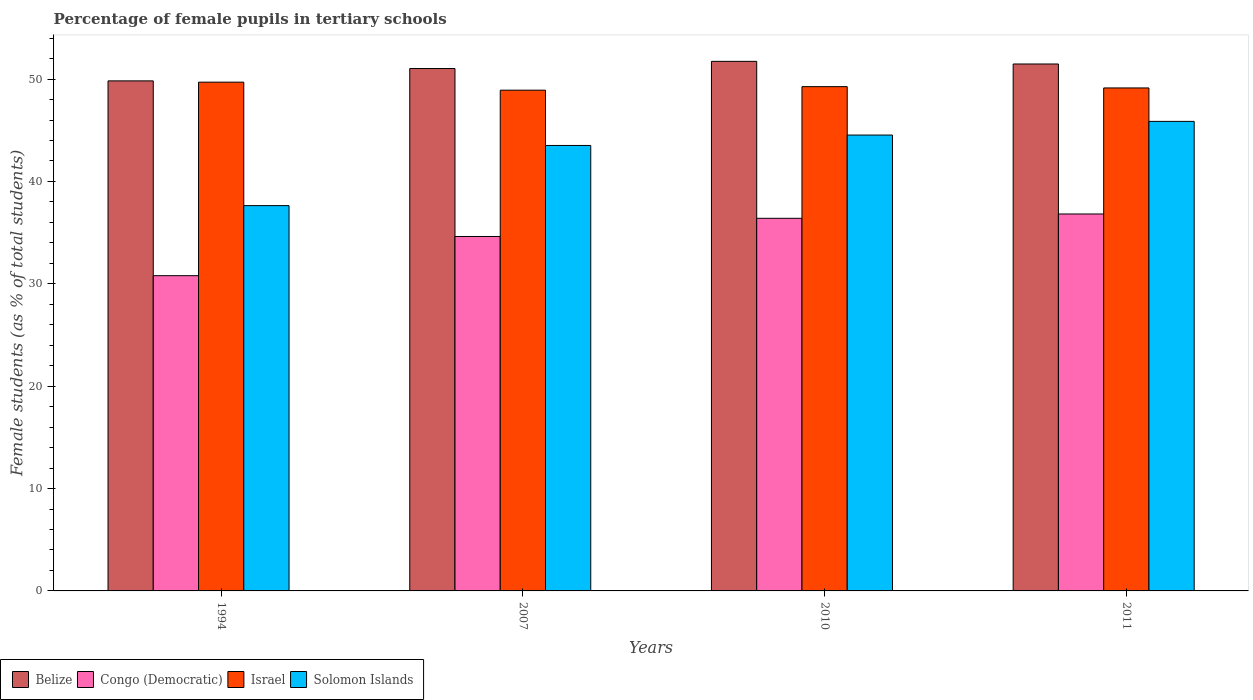How many bars are there on the 2nd tick from the left?
Ensure brevity in your answer.  4. In how many cases, is the number of bars for a given year not equal to the number of legend labels?
Your answer should be compact. 0. What is the percentage of female pupils in tertiary schools in Israel in 2011?
Offer a terse response. 49.14. Across all years, what is the maximum percentage of female pupils in tertiary schools in Solomon Islands?
Offer a terse response. 45.87. Across all years, what is the minimum percentage of female pupils in tertiary schools in Congo (Democratic)?
Offer a terse response. 30.8. In which year was the percentage of female pupils in tertiary schools in Belize maximum?
Provide a succinct answer. 2010. What is the total percentage of female pupils in tertiary schools in Belize in the graph?
Offer a very short reply. 204.07. What is the difference between the percentage of female pupils in tertiary schools in Israel in 2007 and that in 2010?
Offer a terse response. -0.35. What is the difference between the percentage of female pupils in tertiary schools in Belize in 2007 and the percentage of female pupils in tertiary schools in Congo (Democratic) in 2010?
Offer a very short reply. 14.63. What is the average percentage of female pupils in tertiary schools in Congo (Democratic) per year?
Offer a terse response. 34.66. In the year 2010, what is the difference between the percentage of female pupils in tertiary schools in Solomon Islands and percentage of female pupils in tertiary schools in Israel?
Provide a succinct answer. -4.73. In how many years, is the percentage of female pupils in tertiary schools in Congo (Democratic) greater than 14 %?
Provide a succinct answer. 4. What is the ratio of the percentage of female pupils in tertiary schools in Israel in 2007 to that in 2011?
Your response must be concise. 1. What is the difference between the highest and the second highest percentage of female pupils in tertiary schools in Israel?
Offer a terse response. 0.44. What is the difference between the highest and the lowest percentage of female pupils in tertiary schools in Congo (Democratic)?
Ensure brevity in your answer.  6.03. In how many years, is the percentage of female pupils in tertiary schools in Congo (Democratic) greater than the average percentage of female pupils in tertiary schools in Congo (Democratic) taken over all years?
Make the answer very short. 2. Is it the case that in every year, the sum of the percentage of female pupils in tertiary schools in Congo (Democratic) and percentage of female pupils in tertiary schools in Solomon Islands is greater than the sum of percentage of female pupils in tertiary schools in Israel and percentage of female pupils in tertiary schools in Belize?
Provide a short and direct response. No. What does the 4th bar from the left in 2011 represents?
Offer a terse response. Solomon Islands. What does the 3rd bar from the right in 2007 represents?
Your answer should be very brief. Congo (Democratic). Are all the bars in the graph horizontal?
Offer a very short reply. No. What is the difference between two consecutive major ticks on the Y-axis?
Give a very brief answer. 10. Are the values on the major ticks of Y-axis written in scientific E-notation?
Provide a succinct answer. No. Does the graph contain grids?
Your answer should be compact. No. Where does the legend appear in the graph?
Provide a succinct answer. Bottom left. How many legend labels are there?
Your answer should be compact. 4. How are the legend labels stacked?
Your answer should be compact. Horizontal. What is the title of the graph?
Ensure brevity in your answer.  Percentage of female pupils in tertiary schools. What is the label or title of the Y-axis?
Give a very brief answer. Female students (as % of total students). What is the Female students (as % of total students) of Belize in 1994?
Offer a terse response. 49.83. What is the Female students (as % of total students) of Congo (Democratic) in 1994?
Make the answer very short. 30.8. What is the Female students (as % of total students) in Israel in 1994?
Keep it short and to the point. 49.7. What is the Female students (as % of total students) of Solomon Islands in 1994?
Your answer should be very brief. 37.64. What is the Female students (as % of total students) of Belize in 2007?
Your answer should be compact. 51.03. What is the Female students (as % of total students) in Congo (Democratic) in 2007?
Keep it short and to the point. 34.62. What is the Female students (as % of total students) of Israel in 2007?
Provide a short and direct response. 48.92. What is the Female students (as % of total students) in Solomon Islands in 2007?
Your answer should be compact. 43.52. What is the Female students (as % of total students) of Belize in 2010?
Provide a short and direct response. 51.73. What is the Female students (as % of total students) in Congo (Democratic) in 2010?
Your answer should be very brief. 36.4. What is the Female students (as % of total students) in Israel in 2010?
Give a very brief answer. 49.26. What is the Female students (as % of total students) in Solomon Islands in 2010?
Your answer should be very brief. 44.53. What is the Female students (as % of total students) of Belize in 2011?
Offer a terse response. 51.48. What is the Female students (as % of total students) in Congo (Democratic) in 2011?
Make the answer very short. 36.82. What is the Female students (as % of total students) in Israel in 2011?
Give a very brief answer. 49.14. What is the Female students (as % of total students) in Solomon Islands in 2011?
Your answer should be compact. 45.87. Across all years, what is the maximum Female students (as % of total students) of Belize?
Offer a terse response. 51.73. Across all years, what is the maximum Female students (as % of total students) of Congo (Democratic)?
Your answer should be compact. 36.82. Across all years, what is the maximum Female students (as % of total students) of Israel?
Make the answer very short. 49.7. Across all years, what is the maximum Female students (as % of total students) in Solomon Islands?
Provide a short and direct response. 45.87. Across all years, what is the minimum Female students (as % of total students) of Belize?
Your answer should be very brief. 49.83. Across all years, what is the minimum Female students (as % of total students) of Congo (Democratic)?
Your answer should be compact. 30.8. Across all years, what is the minimum Female students (as % of total students) in Israel?
Your answer should be very brief. 48.92. Across all years, what is the minimum Female students (as % of total students) of Solomon Islands?
Give a very brief answer. 37.64. What is the total Female students (as % of total students) in Belize in the graph?
Your answer should be compact. 204.07. What is the total Female students (as % of total students) of Congo (Democratic) in the graph?
Make the answer very short. 138.64. What is the total Female students (as % of total students) in Israel in the graph?
Provide a succinct answer. 197.01. What is the total Female students (as % of total students) in Solomon Islands in the graph?
Make the answer very short. 171.56. What is the difference between the Female students (as % of total students) of Belize in 1994 and that in 2007?
Give a very brief answer. -1.21. What is the difference between the Female students (as % of total students) of Congo (Democratic) in 1994 and that in 2007?
Provide a succinct answer. -3.83. What is the difference between the Female students (as % of total students) in Israel in 1994 and that in 2007?
Your response must be concise. 0.78. What is the difference between the Female students (as % of total students) of Solomon Islands in 1994 and that in 2007?
Ensure brevity in your answer.  -5.88. What is the difference between the Female students (as % of total students) of Belize in 1994 and that in 2010?
Offer a terse response. -1.91. What is the difference between the Female students (as % of total students) of Congo (Democratic) in 1994 and that in 2010?
Offer a terse response. -5.6. What is the difference between the Female students (as % of total students) in Israel in 1994 and that in 2010?
Your answer should be compact. 0.44. What is the difference between the Female students (as % of total students) of Solomon Islands in 1994 and that in 2010?
Ensure brevity in your answer.  -6.89. What is the difference between the Female students (as % of total students) of Belize in 1994 and that in 2011?
Make the answer very short. -1.65. What is the difference between the Female students (as % of total students) in Congo (Democratic) in 1994 and that in 2011?
Provide a short and direct response. -6.03. What is the difference between the Female students (as % of total students) in Israel in 1994 and that in 2011?
Offer a terse response. 0.56. What is the difference between the Female students (as % of total students) in Solomon Islands in 1994 and that in 2011?
Provide a short and direct response. -8.23. What is the difference between the Female students (as % of total students) in Belize in 2007 and that in 2010?
Offer a very short reply. -0.7. What is the difference between the Female students (as % of total students) in Congo (Democratic) in 2007 and that in 2010?
Keep it short and to the point. -1.78. What is the difference between the Female students (as % of total students) in Israel in 2007 and that in 2010?
Provide a short and direct response. -0.35. What is the difference between the Female students (as % of total students) in Solomon Islands in 2007 and that in 2010?
Offer a terse response. -1.02. What is the difference between the Female students (as % of total students) of Belize in 2007 and that in 2011?
Give a very brief answer. -0.44. What is the difference between the Female students (as % of total students) in Congo (Democratic) in 2007 and that in 2011?
Ensure brevity in your answer.  -2.2. What is the difference between the Female students (as % of total students) of Israel in 2007 and that in 2011?
Provide a short and direct response. -0.22. What is the difference between the Female students (as % of total students) in Solomon Islands in 2007 and that in 2011?
Your response must be concise. -2.35. What is the difference between the Female students (as % of total students) of Belize in 2010 and that in 2011?
Provide a short and direct response. 0.26. What is the difference between the Female students (as % of total students) in Congo (Democratic) in 2010 and that in 2011?
Give a very brief answer. -0.42. What is the difference between the Female students (as % of total students) in Israel in 2010 and that in 2011?
Your response must be concise. 0.13. What is the difference between the Female students (as % of total students) in Solomon Islands in 2010 and that in 2011?
Provide a succinct answer. -1.34. What is the difference between the Female students (as % of total students) of Belize in 1994 and the Female students (as % of total students) of Congo (Democratic) in 2007?
Your answer should be very brief. 15.2. What is the difference between the Female students (as % of total students) of Belize in 1994 and the Female students (as % of total students) of Israel in 2007?
Your answer should be very brief. 0.91. What is the difference between the Female students (as % of total students) in Belize in 1994 and the Female students (as % of total students) in Solomon Islands in 2007?
Ensure brevity in your answer.  6.31. What is the difference between the Female students (as % of total students) in Congo (Democratic) in 1994 and the Female students (as % of total students) in Israel in 2007?
Keep it short and to the point. -18.12. What is the difference between the Female students (as % of total students) of Congo (Democratic) in 1994 and the Female students (as % of total students) of Solomon Islands in 2007?
Your answer should be compact. -12.72. What is the difference between the Female students (as % of total students) in Israel in 1994 and the Female students (as % of total students) in Solomon Islands in 2007?
Offer a terse response. 6.18. What is the difference between the Female students (as % of total students) of Belize in 1994 and the Female students (as % of total students) of Congo (Democratic) in 2010?
Provide a succinct answer. 13.42. What is the difference between the Female students (as % of total students) in Belize in 1994 and the Female students (as % of total students) in Israel in 2010?
Ensure brevity in your answer.  0.56. What is the difference between the Female students (as % of total students) in Belize in 1994 and the Female students (as % of total students) in Solomon Islands in 2010?
Provide a short and direct response. 5.29. What is the difference between the Female students (as % of total students) of Congo (Democratic) in 1994 and the Female students (as % of total students) of Israel in 2010?
Provide a succinct answer. -18.47. What is the difference between the Female students (as % of total students) in Congo (Democratic) in 1994 and the Female students (as % of total students) in Solomon Islands in 2010?
Your answer should be very brief. -13.74. What is the difference between the Female students (as % of total students) in Israel in 1994 and the Female students (as % of total students) in Solomon Islands in 2010?
Make the answer very short. 5.17. What is the difference between the Female students (as % of total students) of Belize in 1994 and the Female students (as % of total students) of Congo (Democratic) in 2011?
Ensure brevity in your answer.  13. What is the difference between the Female students (as % of total students) in Belize in 1994 and the Female students (as % of total students) in Israel in 2011?
Offer a very short reply. 0.69. What is the difference between the Female students (as % of total students) of Belize in 1994 and the Female students (as % of total students) of Solomon Islands in 2011?
Make the answer very short. 3.96. What is the difference between the Female students (as % of total students) in Congo (Democratic) in 1994 and the Female students (as % of total students) in Israel in 2011?
Give a very brief answer. -18.34. What is the difference between the Female students (as % of total students) of Congo (Democratic) in 1994 and the Female students (as % of total students) of Solomon Islands in 2011?
Offer a terse response. -15.07. What is the difference between the Female students (as % of total students) of Israel in 1994 and the Female students (as % of total students) of Solomon Islands in 2011?
Offer a terse response. 3.83. What is the difference between the Female students (as % of total students) in Belize in 2007 and the Female students (as % of total students) in Congo (Democratic) in 2010?
Provide a short and direct response. 14.63. What is the difference between the Female students (as % of total students) of Belize in 2007 and the Female students (as % of total students) of Israel in 2010?
Provide a succinct answer. 1.77. What is the difference between the Female students (as % of total students) of Belize in 2007 and the Female students (as % of total students) of Solomon Islands in 2010?
Give a very brief answer. 6.5. What is the difference between the Female students (as % of total students) in Congo (Democratic) in 2007 and the Female students (as % of total students) in Israel in 2010?
Give a very brief answer. -14.64. What is the difference between the Female students (as % of total students) of Congo (Democratic) in 2007 and the Female students (as % of total students) of Solomon Islands in 2010?
Your answer should be very brief. -9.91. What is the difference between the Female students (as % of total students) in Israel in 2007 and the Female students (as % of total students) in Solomon Islands in 2010?
Make the answer very short. 4.38. What is the difference between the Female students (as % of total students) of Belize in 2007 and the Female students (as % of total students) of Congo (Democratic) in 2011?
Your response must be concise. 14.21. What is the difference between the Female students (as % of total students) of Belize in 2007 and the Female students (as % of total students) of Israel in 2011?
Make the answer very short. 1.9. What is the difference between the Female students (as % of total students) in Belize in 2007 and the Female students (as % of total students) in Solomon Islands in 2011?
Provide a short and direct response. 5.16. What is the difference between the Female students (as % of total students) in Congo (Democratic) in 2007 and the Female students (as % of total students) in Israel in 2011?
Make the answer very short. -14.51. What is the difference between the Female students (as % of total students) in Congo (Democratic) in 2007 and the Female students (as % of total students) in Solomon Islands in 2011?
Provide a short and direct response. -11.24. What is the difference between the Female students (as % of total students) in Israel in 2007 and the Female students (as % of total students) in Solomon Islands in 2011?
Your answer should be compact. 3.05. What is the difference between the Female students (as % of total students) in Belize in 2010 and the Female students (as % of total students) in Congo (Democratic) in 2011?
Keep it short and to the point. 14.91. What is the difference between the Female students (as % of total students) of Belize in 2010 and the Female students (as % of total students) of Israel in 2011?
Ensure brevity in your answer.  2.6. What is the difference between the Female students (as % of total students) of Belize in 2010 and the Female students (as % of total students) of Solomon Islands in 2011?
Your answer should be very brief. 5.87. What is the difference between the Female students (as % of total students) of Congo (Democratic) in 2010 and the Female students (as % of total students) of Israel in 2011?
Give a very brief answer. -12.74. What is the difference between the Female students (as % of total students) in Congo (Democratic) in 2010 and the Female students (as % of total students) in Solomon Islands in 2011?
Offer a very short reply. -9.47. What is the difference between the Female students (as % of total students) in Israel in 2010 and the Female students (as % of total students) in Solomon Islands in 2011?
Give a very brief answer. 3.39. What is the average Female students (as % of total students) of Belize per year?
Offer a terse response. 51.02. What is the average Female students (as % of total students) of Congo (Democratic) per year?
Keep it short and to the point. 34.66. What is the average Female students (as % of total students) in Israel per year?
Ensure brevity in your answer.  49.25. What is the average Female students (as % of total students) in Solomon Islands per year?
Your response must be concise. 42.89. In the year 1994, what is the difference between the Female students (as % of total students) of Belize and Female students (as % of total students) of Congo (Democratic)?
Offer a very short reply. 19.03. In the year 1994, what is the difference between the Female students (as % of total students) in Belize and Female students (as % of total students) in Israel?
Ensure brevity in your answer.  0.13. In the year 1994, what is the difference between the Female students (as % of total students) of Belize and Female students (as % of total students) of Solomon Islands?
Offer a very short reply. 12.19. In the year 1994, what is the difference between the Female students (as % of total students) in Congo (Democratic) and Female students (as % of total students) in Israel?
Your answer should be compact. -18.9. In the year 1994, what is the difference between the Female students (as % of total students) in Congo (Democratic) and Female students (as % of total students) in Solomon Islands?
Offer a terse response. -6.84. In the year 1994, what is the difference between the Female students (as % of total students) in Israel and Female students (as % of total students) in Solomon Islands?
Keep it short and to the point. 12.06. In the year 2007, what is the difference between the Female students (as % of total students) in Belize and Female students (as % of total students) in Congo (Democratic)?
Your answer should be compact. 16.41. In the year 2007, what is the difference between the Female students (as % of total students) in Belize and Female students (as % of total students) in Israel?
Ensure brevity in your answer.  2.12. In the year 2007, what is the difference between the Female students (as % of total students) of Belize and Female students (as % of total students) of Solomon Islands?
Make the answer very short. 7.52. In the year 2007, what is the difference between the Female students (as % of total students) of Congo (Democratic) and Female students (as % of total students) of Israel?
Offer a terse response. -14.29. In the year 2007, what is the difference between the Female students (as % of total students) in Congo (Democratic) and Female students (as % of total students) in Solomon Islands?
Your answer should be compact. -8.89. In the year 2007, what is the difference between the Female students (as % of total students) in Israel and Female students (as % of total students) in Solomon Islands?
Keep it short and to the point. 5.4. In the year 2010, what is the difference between the Female students (as % of total students) in Belize and Female students (as % of total students) in Congo (Democratic)?
Ensure brevity in your answer.  15.33. In the year 2010, what is the difference between the Female students (as % of total students) of Belize and Female students (as % of total students) of Israel?
Provide a short and direct response. 2.47. In the year 2010, what is the difference between the Female students (as % of total students) of Belize and Female students (as % of total students) of Solomon Islands?
Keep it short and to the point. 7.2. In the year 2010, what is the difference between the Female students (as % of total students) in Congo (Democratic) and Female students (as % of total students) in Israel?
Your answer should be compact. -12.86. In the year 2010, what is the difference between the Female students (as % of total students) in Congo (Democratic) and Female students (as % of total students) in Solomon Islands?
Offer a terse response. -8.13. In the year 2010, what is the difference between the Female students (as % of total students) in Israel and Female students (as % of total students) in Solomon Islands?
Your answer should be very brief. 4.73. In the year 2011, what is the difference between the Female students (as % of total students) in Belize and Female students (as % of total students) in Congo (Democratic)?
Your answer should be very brief. 14.65. In the year 2011, what is the difference between the Female students (as % of total students) in Belize and Female students (as % of total students) in Israel?
Make the answer very short. 2.34. In the year 2011, what is the difference between the Female students (as % of total students) in Belize and Female students (as % of total students) in Solomon Islands?
Give a very brief answer. 5.61. In the year 2011, what is the difference between the Female students (as % of total students) in Congo (Democratic) and Female students (as % of total students) in Israel?
Give a very brief answer. -12.31. In the year 2011, what is the difference between the Female students (as % of total students) of Congo (Democratic) and Female students (as % of total students) of Solomon Islands?
Your answer should be very brief. -9.05. In the year 2011, what is the difference between the Female students (as % of total students) of Israel and Female students (as % of total students) of Solomon Islands?
Your answer should be compact. 3.27. What is the ratio of the Female students (as % of total students) of Belize in 1994 to that in 2007?
Offer a terse response. 0.98. What is the ratio of the Female students (as % of total students) of Congo (Democratic) in 1994 to that in 2007?
Offer a very short reply. 0.89. What is the ratio of the Female students (as % of total students) of Israel in 1994 to that in 2007?
Your answer should be compact. 1.02. What is the ratio of the Female students (as % of total students) in Solomon Islands in 1994 to that in 2007?
Provide a succinct answer. 0.86. What is the ratio of the Female students (as % of total students) of Belize in 1994 to that in 2010?
Provide a short and direct response. 0.96. What is the ratio of the Female students (as % of total students) in Congo (Democratic) in 1994 to that in 2010?
Provide a short and direct response. 0.85. What is the ratio of the Female students (as % of total students) of Israel in 1994 to that in 2010?
Give a very brief answer. 1.01. What is the ratio of the Female students (as % of total students) in Solomon Islands in 1994 to that in 2010?
Give a very brief answer. 0.85. What is the ratio of the Female students (as % of total students) in Belize in 1994 to that in 2011?
Offer a terse response. 0.97. What is the ratio of the Female students (as % of total students) of Congo (Democratic) in 1994 to that in 2011?
Your response must be concise. 0.84. What is the ratio of the Female students (as % of total students) in Israel in 1994 to that in 2011?
Give a very brief answer. 1.01. What is the ratio of the Female students (as % of total students) in Solomon Islands in 1994 to that in 2011?
Offer a very short reply. 0.82. What is the ratio of the Female students (as % of total students) of Belize in 2007 to that in 2010?
Your answer should be very brief. 0.99. What is the ratio of the Female students (as % of total students) of Congo (Democratic) in 2007 to that in 2010?
Ensure brevity in your answer.  0.95. What is the ratio of the Female students (as % of total students) in Israel in 2007 to that in 2010?
Provide a short and direct response. 0.99. What is the ratio of the Female students (as % of total students) of Solomon Islands in 2007 to that in 2010?
Your answer should be compact. 0.98. What is the ratio of the Female students (as % of total students) in Belize in 2007 to that in 2011?
Offer a very short reply. 0.99. What is the ratio of the Female students (as % of total students) in Congo (Democratic) in 2007 to that in 2011?
Offer a terse response. 0.94. What is the ratio of the Female students (as % of total students) in Solomon Islands in 2007 to that in 2011?
Give a very brief answer. 0.95. What is the ratio of the Female students (as % of total students) of Belize in 2010 to that in 2011?
Provide a succinct answer. 1. What is the ratio of the Female students (as % of total students) in Congo (Democratic) in 2010 to that in 2011?
Your response must be concise. 0.99. What is the ratio of the Female students (as % of total students) in Israel in 2010 to that in 2011?
Offer a very short reply. 1. What is the ratio of the Female students (as % of total students) in Solomon Islands in 2010 to that in 2011?
Offer a terse response. 0.97. What is the difference between the highest and the second highest Female students (as % of total students) of Belize?
Ensure brevity in your answer.  0.26. What is the difference between the highest and the second highest Female students (as % of total students) in Congo (Democratic)?
Provide a succinct answer. 0.42. What is the difference between the highest and the second highest Female students (as % of total students) in Israel?
Provide a short and direct response. 0.44. What is the difference between the highest and the second highest Female students (as % of total students) of Solomon Islands?
Give a very brief answer. 1.34. What is the difference between the highest and the lowest Female students (as % of total students) of Belize?
Your response must be concise. 1.91. What is the difference between the highest and the lowest Female students (as % of total students) in Congo (Democratic)?
Give a very brief answer. 6.03. What is the difference between the highest and the lowest Female students (as % of total students) of Israel?
Offer a very short reply. 0.78. What is the difference between the highest and the lowest Female students (as % of total students) of Solomon Islands?
Offer a terse response. 8.23. 